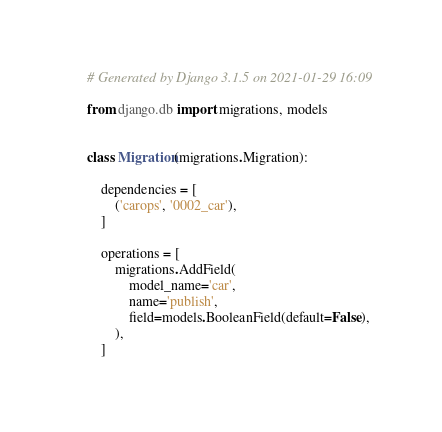Convert code to text. <code><loc_0><loc_0><loc_500><loc_500><_Python_># Generated by Django 3.1.5 on 2021-01-29 16:09

from django.db import migrations, models


class Migration(migrations.Migration):

    dependencies = [
        ('carops', '0002_car'),
    ]

    operations = [
        migrations.AddField(
            model_name='car',
            name='publish',
            field=models.BooleanField(default=False),
        ),
    ]
</code> 